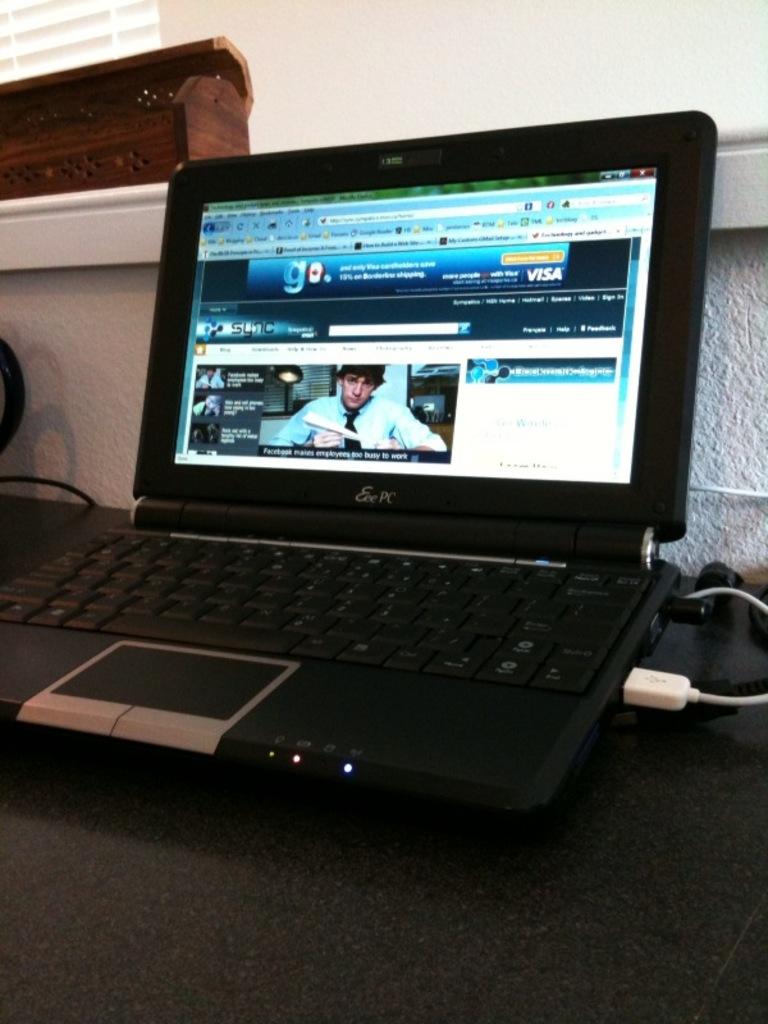What brand is this device?
Your answer should be very brief. Eee pc. 